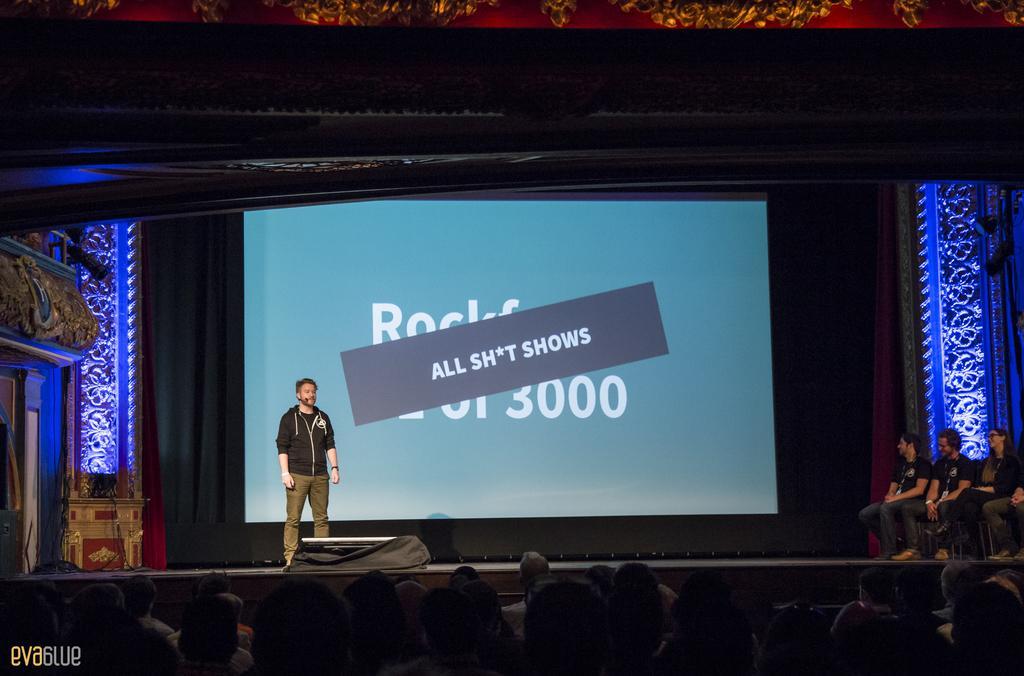Describe this image in one or two sentences. This picture seems to be clicked inside the hall. In the foreground we can see the group of persons. On the right corner we can see the group of persons seems to be sitting on the chairs and on the left we can see a person wearing black color dress and standing. In the background we can see the text and numbers on the projector screen and we can see the curtain and some other objects. In the bottom left corner we can see the text on the image. 